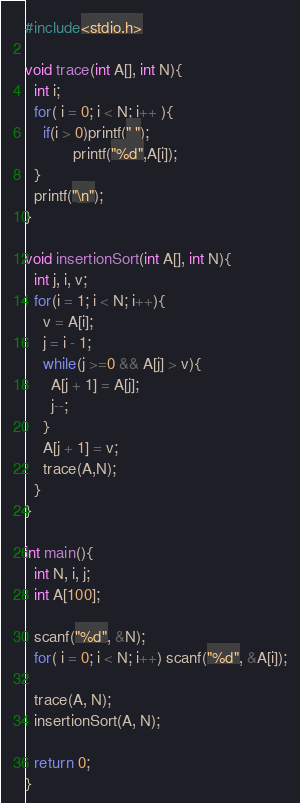Convert code to text. <code><loc_0><loc_0><loc_500><loc_500><_C_>#include<stdio.h>

void trace(int A[], int N){
  int i;
  for( i = 0; i < N; i++ ){
    if(i > 0)printf(" ");
	       printf("%d",A[i]);
  }
  printf("\n");
}

void insertionSort(int A[], int N){
  int j, i, v;
  for(i = 1; i < N; i++){
    v = A[i];
    j = i - 1;
    while(j >=0 && A[j] > v){
      A[j + 1] = A[j];
      j--;
    }
    A[j + 1] = v;
    trace(A,N);
  }
}

int main(){
  int N, i, j;
  int A[100];

  scanf("%d", &N);
  for( i = 0; i < N; i++) scanf("%d", &A[i]);

  trace(A, N);
  insertionSort(A, N);

  return 0;
}</code> 